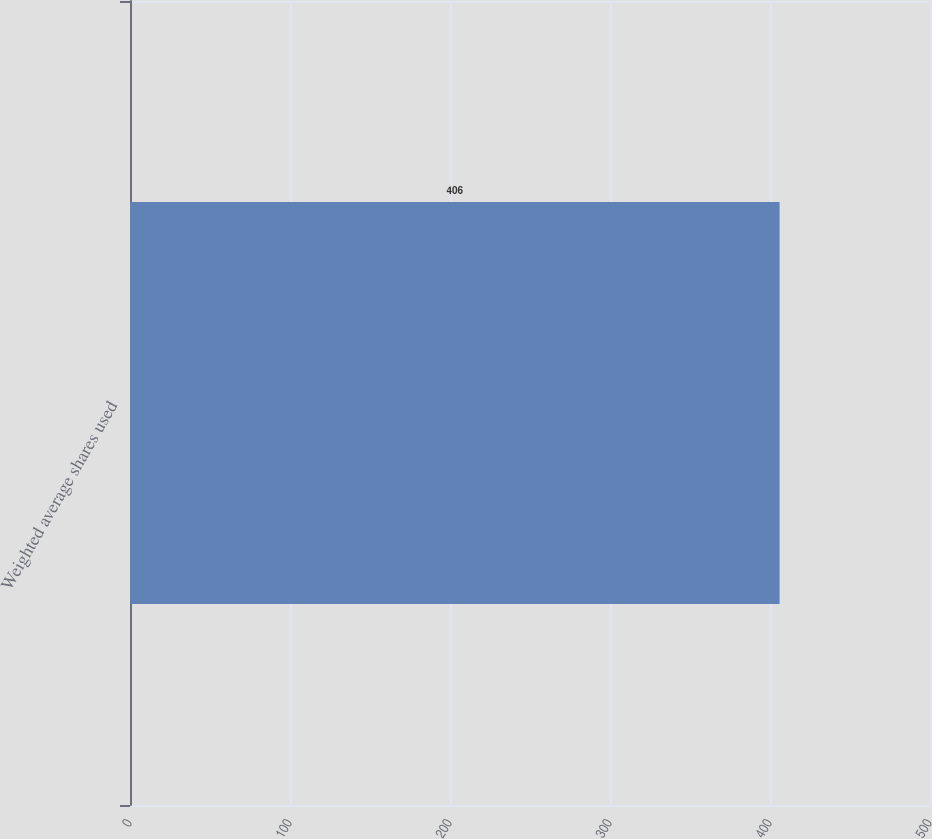Convert chart. <chart><loc_0><loc_0><loc_500><loc_500><bar_chart><fcel>Weighted average shares used<nl><fcel>406<nl></chart> 